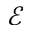Convert formula to latex. <formula><loc_0><loc_0><loc_500><loc_500>\mathcal { E }</formula> 